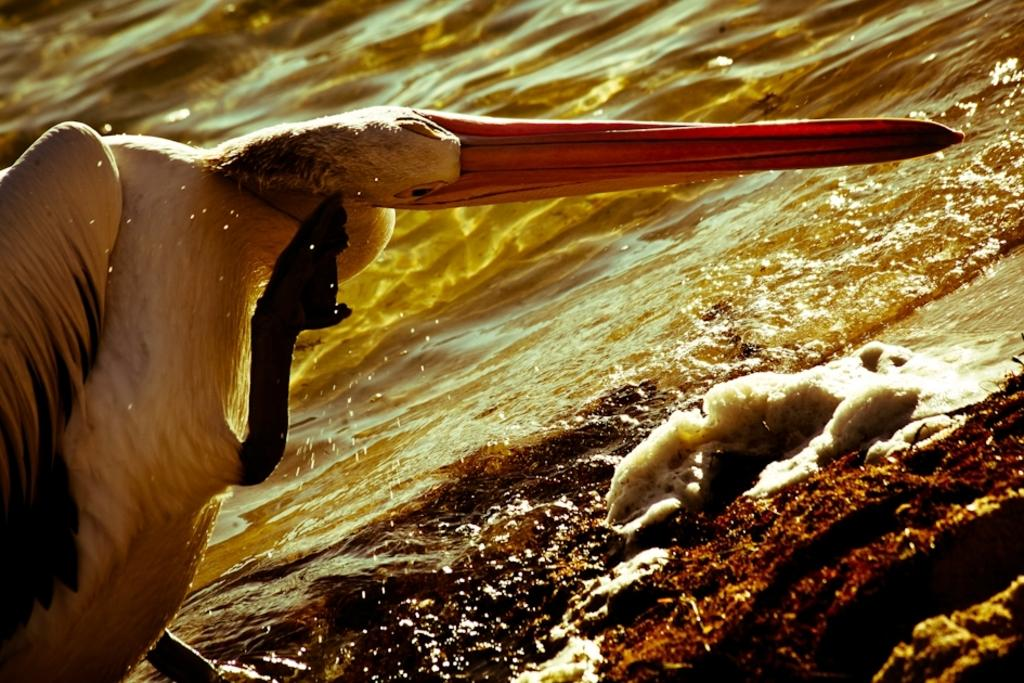What type of animal is present in the image? There is an animal in the image, but the specific type cannot be determined from the provided facts. What can be seen in the background of the image? There is water flowing in the background of the image. Is there a crook trying to catch the animal in the image? There is no mention of a crook or any attempt to catch the animal in the image. Where is the camp located in the image? There is no camp present in the image. Can you see an airplane flying in the image? There is no airplane visible in the image. 